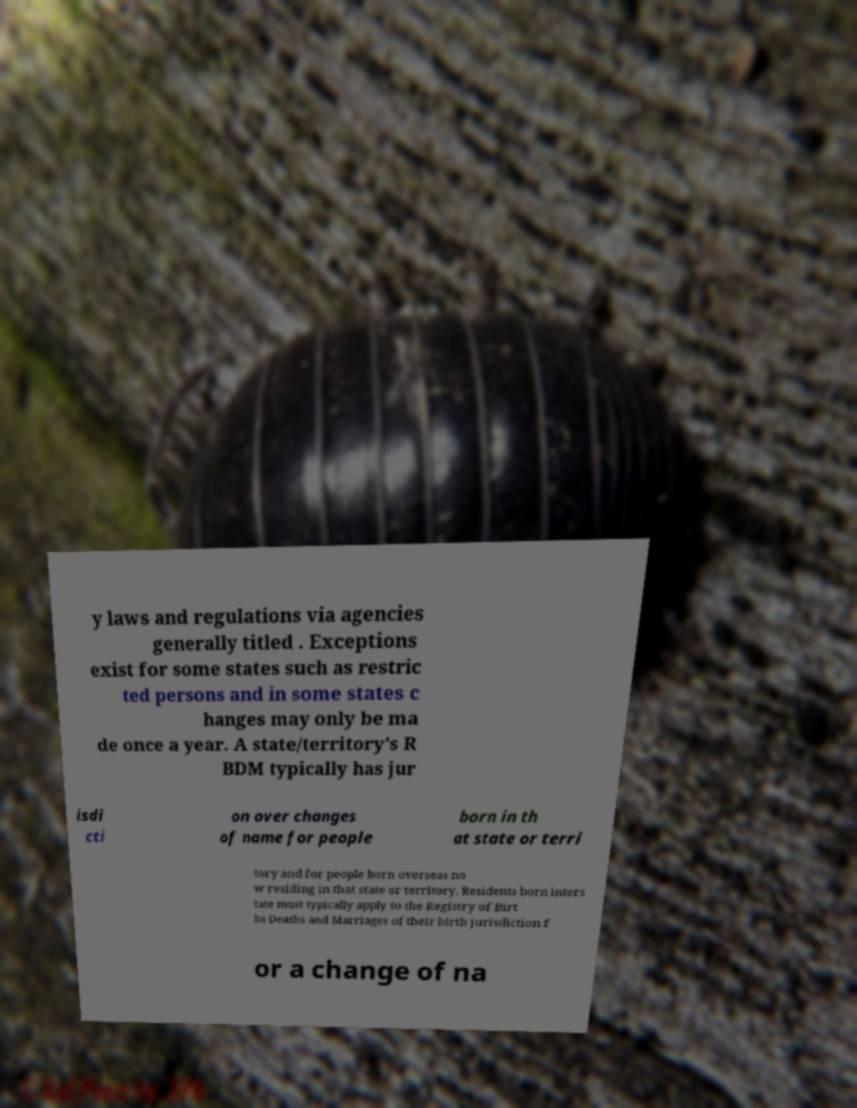For documentation purposes, I need the text within this image transcribed. Could you provide that? y laws and regulations via agencies generally titled . Exceptions exist for some states such as restric ted persons and in some states c hanges may only be ma de once a year. A state/territory's R BDM typically has jur isdi cti on over changes of name for people born in th at state or terri tory and for people born overseas no w residing in that state or territory. Residents born inters tate must typically apply to the Registry of Birt hs Deaths and Marriages of their birth jurisdiction f or a change of na 